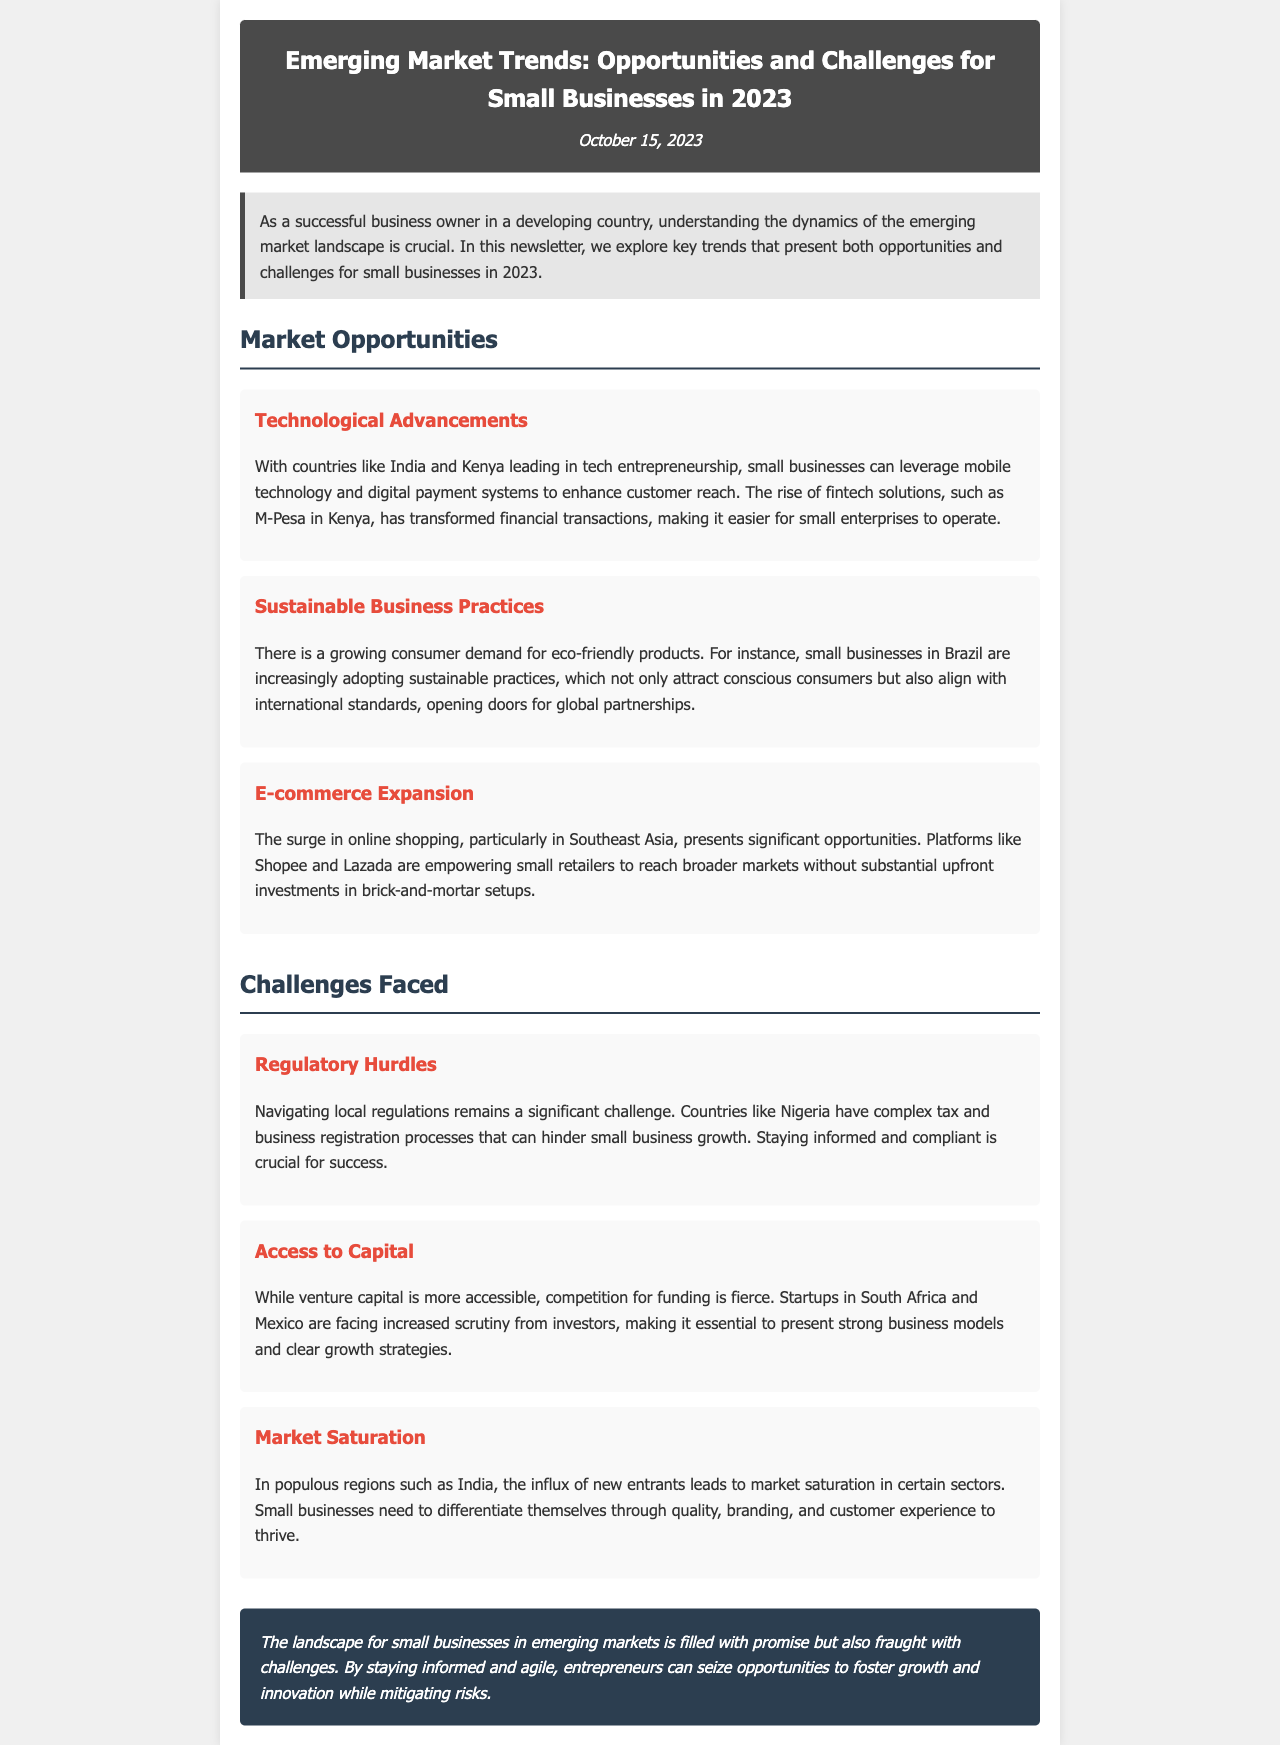What is the date of the newsletter? The date is mentioned in the header section of the document.
Answer: October 15, 2023 Which country is mentioned as leading in tech entrepreneurship? The document specifically highlights one country in the context of technological advancements.
Answer: India What consumer trend is discussed in relation to Brazil? The document states the trend related to small businesses in Brazil.
Answer: Sustainable practices What is the name of the fintech solution mentioned in Kenya? The document explicitly names this fintech solution as a leading example in the section about technological advancements.
Answer: M-Pesa What challenge is associated with regulatory issues? The document identifies a particular challenge pertaining to local regulations that affects small businesses.
Answer: Complex tax and business registration processes Which two countries are mentioned in the context of access to capital issues? These countries are highlighted in the section discussing challenges faced by small businesses seeking funding.
Answer: South Africa and Mexico What is the concluding message of the newsletter? The document summarizes the overall sentiment regarding the future of small businesses in emerging markets.
Answer: Filled with promise but also fraught with challenges How are e-commerce platforms affecting small retailers? The document discusses the impact of e-commerce on small business operations.
Answer: Empowering small retailers to reach broader markets 